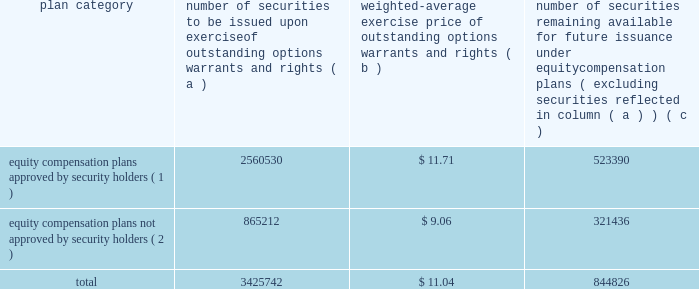Part iii item 10 .
Directors and executive officers of the registrant .
Pursuant to section 406 of the sarbanes-oxley act of 2002 , we have adopted a code of ethics for senior financial officers that applies to our principal executive officer and principal financial officer , principal accounting officer and controller , and other persons performing similar functions .
Our code of ethics for senior financial officers is publicly available on our website at www.hologic.com.we intend to satisfy the disclosure requirement under item 5.05 of current report on form 8-k regarding an amendment to , or waiver from , a provision of this code by posting such information on our website , at the address specified above .
The additional information required by this item is incorporated by reference to our definitive proxy statement for our annual meeting of stockholders to be filed with the securities and exchange commission within 120 days after the close of our fiscal year .
Item 11 .
Executive compensation .
The information required by this item is incorporated by reference to our definitive proxy statement for our annual meeting of stockholders to be filed with the securities and exchange commission within 120 days after the close of our fiscal year .
Item 12 .
Security ownership of certain beneficial owners and management and related stockholder matters .
We maintain a number of equity compensation plans for employees , officers , directors and others whose efforts contribute to our success .
The table below sets forth certain information as our fiscal year ended september 25 , 2004 regarding the shares of our common stock available for grant or granted under stock option plans that ( i ) were approved by our stockholders , and ( ii ) were not approved by our stockholders .
Equity compensation plan information plan category number of securities to be issued upon exercise of outstanding options , warrants and rights weighted-average exercise price of outstanding options , warrants and rights number of securities remaining available for future issuance under equity compensation plans ( excluding securities reflected in column ( a ) ) equity compensation plans approved by security holders ( 1 ) .
2560530 $ 11.71 523390 equity compensation plans not approved by security holders ( 2 ) .
865212 $ 9.06 321436 .
( 1 ) includes the following plans : 1986 combination stock option plan ; amended and restated 1990 non-employee director stock option plan ; 1995 combination stock option plan ; amended and restated 1999 equity incentive plan ; and 2000 employee stock purchase plan .
Also includes the following plans which we assumed in connection with our acquisition of fluoroscan imaging systems in 1996 : fluoroscan imaging systems , inc .
1994 amended and restated stock incentive plan and fluoroscan imaging systems , inc .
1995 stock incentive plan .
For a description of these plans , please refer to footnote 5 contained in our consolidated financial statements. .
What would the total cash impact be if all outstanding options warrants and rights were exercised? 
Computations: (11.04 * 3425742)
Answer: 37820191.68. 